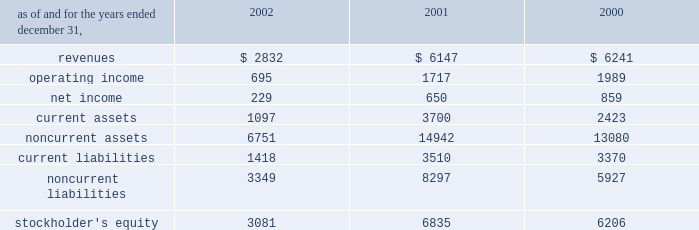Affiliated company .
The loss recorded on the sale was approximately $ 14 million and is recorded as a loss on sale of assets and asset impairment expenses in the accompanying consolidated statements of operations .
In the second quarter of 2002 , the company recorded an impairment charge of approximately $ 40 million , after income taxes , on an equity method investment in a telecommunications company in latin america held by edc .
The impairment charge resulted from sustained poor operating performance coupled with recent funding problems at the invested company .
During 2001 , the company lost operational control of central electricity supply corporation ( 2018 2018cesco 2019 2019 ) , a distribution company located in the state of orissa , india .
Cesco is accounted for as a cost method investment .
In may 2000 , the company completed the acquisition of 100% ( 100 % ) of tractebel power ltd ( 2018 2018tpl 2019 2019 ) for approximately $ 67 million and assumed liabilities of approximately $ 200 million .
Tpl owned 46% ( 46 % ) of nigen .
The company also acquired an additional 6% ( 6 % ) interest in nigen from minority stockholders during the year ended december 31 , 2000 through the issuance of approximately 99000 common shares of aes stock valued at approximately $ 4.9 million .
With the completion of these transactions , the company owns approximately 98% ( 98 % ) of nigen 2019s common stock and began consolidating its financial results beginning may 12 , 2000 .
Approximately $ 100 million of the purchase price was allocated to excess of costs over net assets acquired and was amortized through january 1 , 2002 at which time the company adopted sfas no .
142 and ceased amortization of goodwill .
In august 2000 , a subsidiary of the company acquired a 49% ( 49 % ) interest in songas limited ( 2018 2018songas 2019 2019 ) for approximately $ 40 million .
The company acquired an additional 16.79% ( 16.79 % ) of songas for approximately $ 12.5 million , and the company began consolidating this entity in 2002 .
Songas owns the songo songo gas-to-electricity project in tanzania .
In december 2002 , the company signed a sales purchase agreement to sell songas .
The sale is expected to close in early 2003 .
See note 4 for further discussion of the transaction .
The table presents summarized comparative financial information ( in millions ) for the company 2019s investments in 50% ( 50 % ) or less owned investments accounted for using the equity method. .
In 2002 , 2001 and 2000 , the results of operations and the financial position of cemig were negatively impacted by the devaluation of the brazilian real and the impairment charge recorded in 2002 .
The brazilian real devalued 32% ( 32 % ) , 19% ( 19 % ) and 8% ( 8 % ) for the years ended december 31 , 2002 , 2001 and 2000 , respectively .
The company recorded $ 83 million , $ 210 million , and $ 64 million of pre-tax non-cash foreign currency transaction losses on its investments in brazilian equity method affiliates during 2002 , 2001 and 2000 , respectively. .
What was the percentage change in revenues for investments in 50% ( 50 % ) or less owned investments accounted for using the equity method between 2000 and 2001? 
Computations: ((6147 - 6241) / 6241)
Answer: -0.01506. 